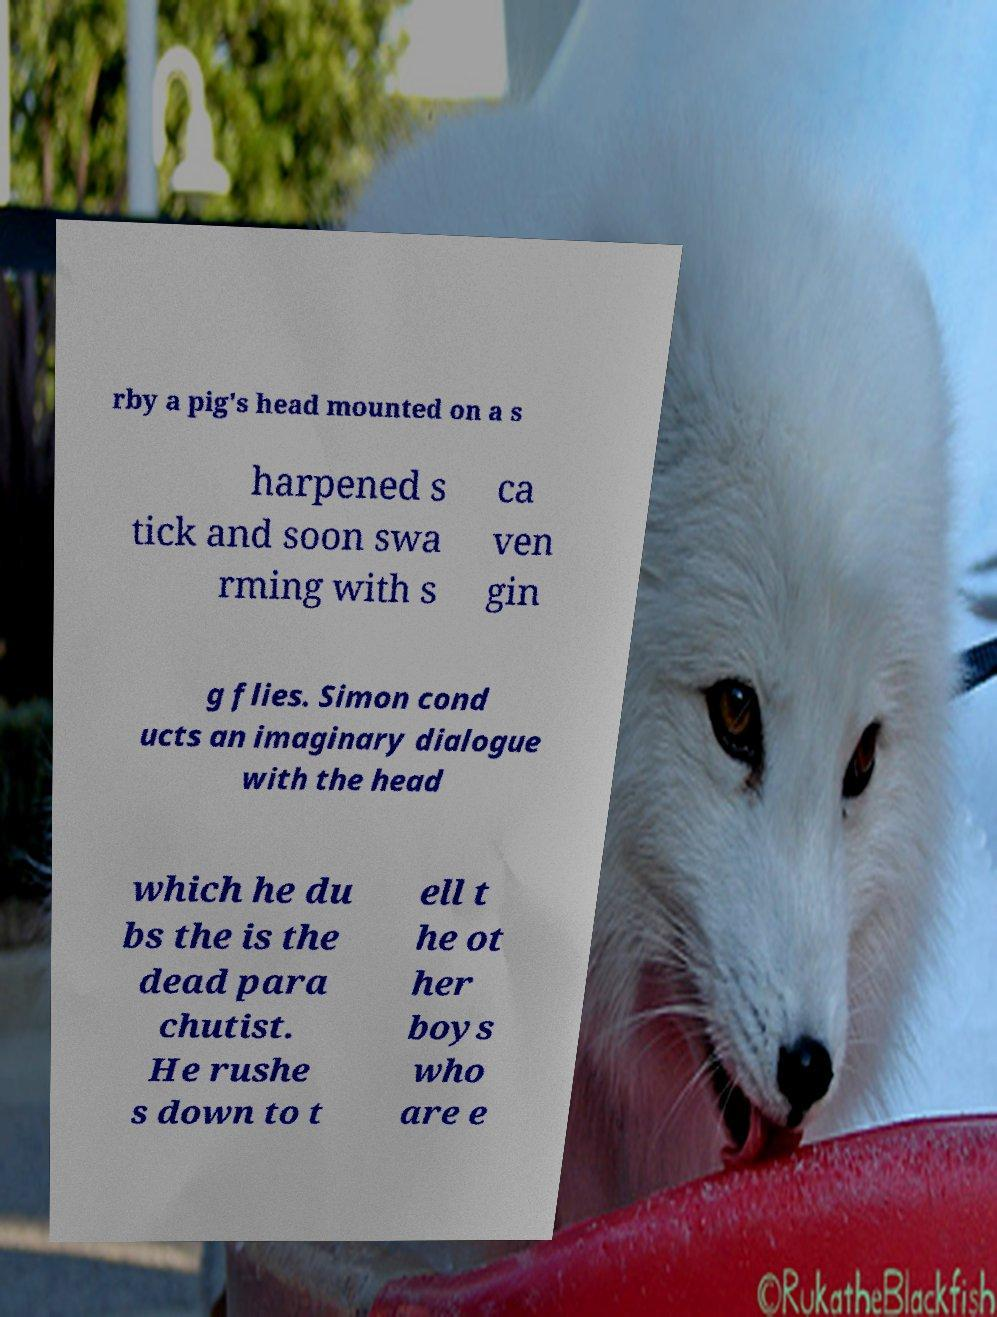What messages or text are displayed in this image? I need them in a readable, typed format. rby a pig's head mounted on a s harpened s tick and soon swa rming with s ca ven gin g flies. Simon cond ucts an imaginary dialogue with the head which he du bs the is the dead para chutist. He rushe s down to t ell t he ot her boys who are e 